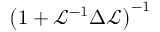Convert formula to latex. <formula><loc_0><loc_0><loc_500><loc_500>\left ( 1 + \mathcal { L } ^ { - 1 } \Delta \mathcal { L } \right ) ^ { - 1 }</formula> 